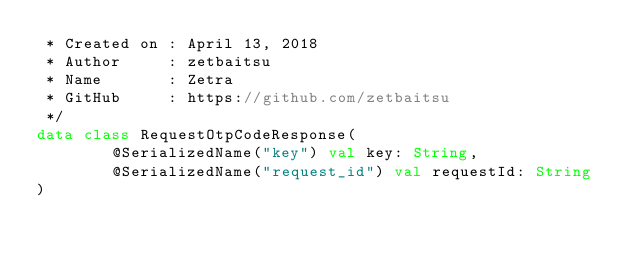Convert code to text. <code><loc_0><loc_0><loc_500><loc_500><_Kotlin_> * Created on : April 13, 2018
 * Author     : zetbaitsu
 * Name       : Zetra
 * GitHub     : https://github.com/zetbaitsu
 */
data class RequestOtpCodeResponse(
        @SerializedName("key") val key: String,
        @SerializedName("request_id") val requestId: String
)</code> 